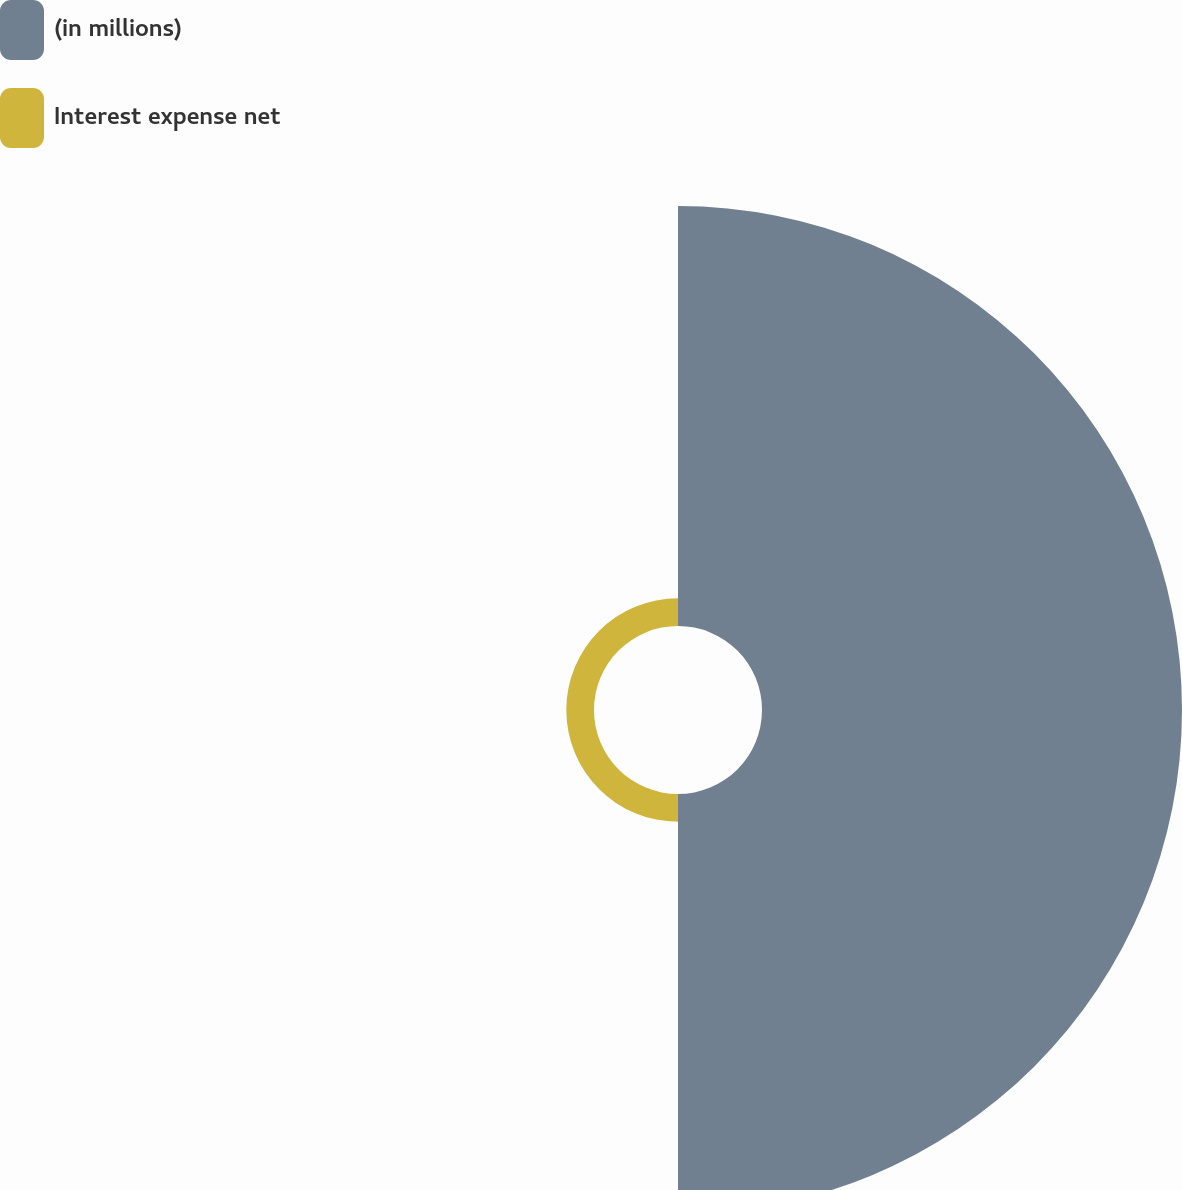<chart> <loc_0><loc_0><loc_500><loc_500><pie_chart><fcel>(in millions)<fcel>Interest expense net<nl><fcel>93.81%<fcel>6.19%<nl></chart> 